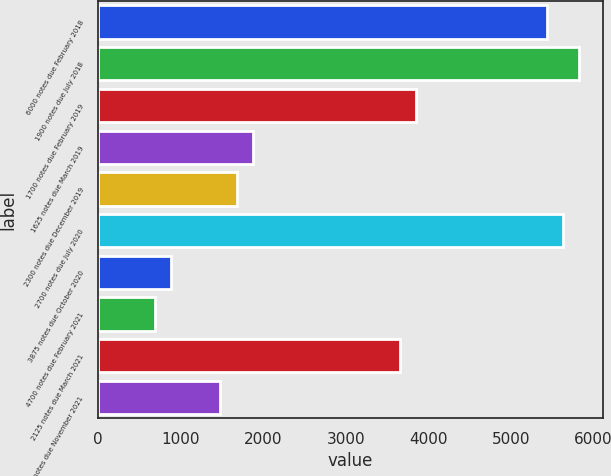Convert chart. <chart><loc_0><loc_0><loc_500><loc_500><bar_chart><fcel>6000 notes due February 2018<fcel>1900 notes due July 2018<fcel>1700 notes due February 2019<fcel>1625 notes due March 2019<fcel>2300 notes due December 2019<fcel>2700 notes due July 2020<fcel>3875 notes due October 2020<fcel>4700 notes due February 2021<fcel>2125 notes due March 2021<fcel>3375 notes due November 2021<nl><fcel>5431<fcel>5826<fcel>3851<fcel>1876<fcel>1678.5<fcel>5628.5<fcel>888.5<fcel>691<fcel>3653.5<fcel>1481<nl></chart> 